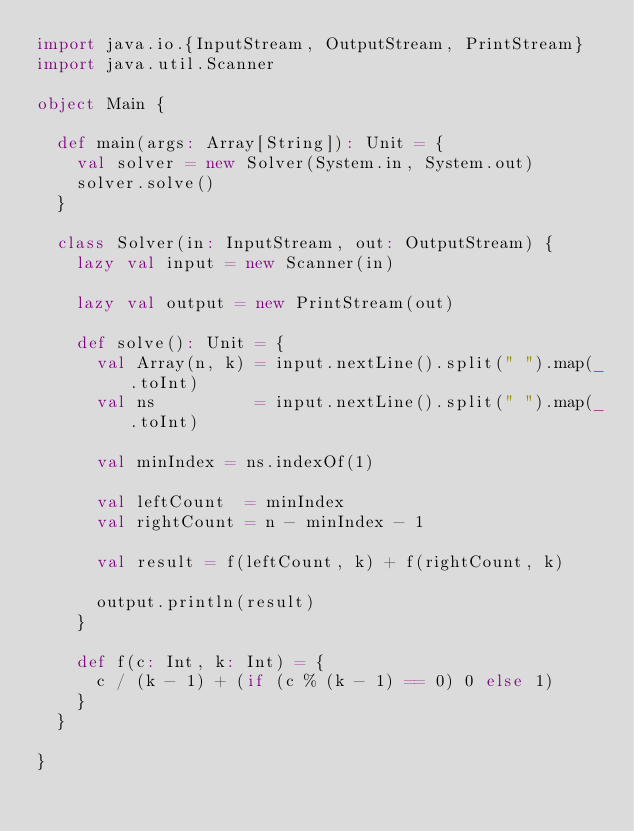<code> <loc_0><loc_0><loc_500><loc_500><_Scala_>import java.io.{InputStream, OutputStream, PrintStream}
import java.util.Scanner

object Main {

  def main(args: Array[String]): Unit = {
    val solver = new Solver(System.in, System.out)
    solver.solve()
  }

  class Solver(in: InputStream, out: OutputStream) {
    lazy val input = new Scanner(in)

    lazy val output = new PrintStream(out)

    def solve(): Unit = {
      val Array(n, k) = input.nextLine().split(" ").map(_.toInt)
      val ns          = input.nextLine().split(" ").map(_.toInt)

      val minIndex = ns.indexOf(1)

      val leftCount  = minIndex
      val rightCount = n - minIndex - 1

      val result = f(leftCount, k) + f(rightCount, k)

      output.println(result)
    }

    def f(c: Int, k: Int) = {
      c / (k - 1) + (if (c % (k - 1) == 0) 0 else 1)
    }
  }

}
</code> 